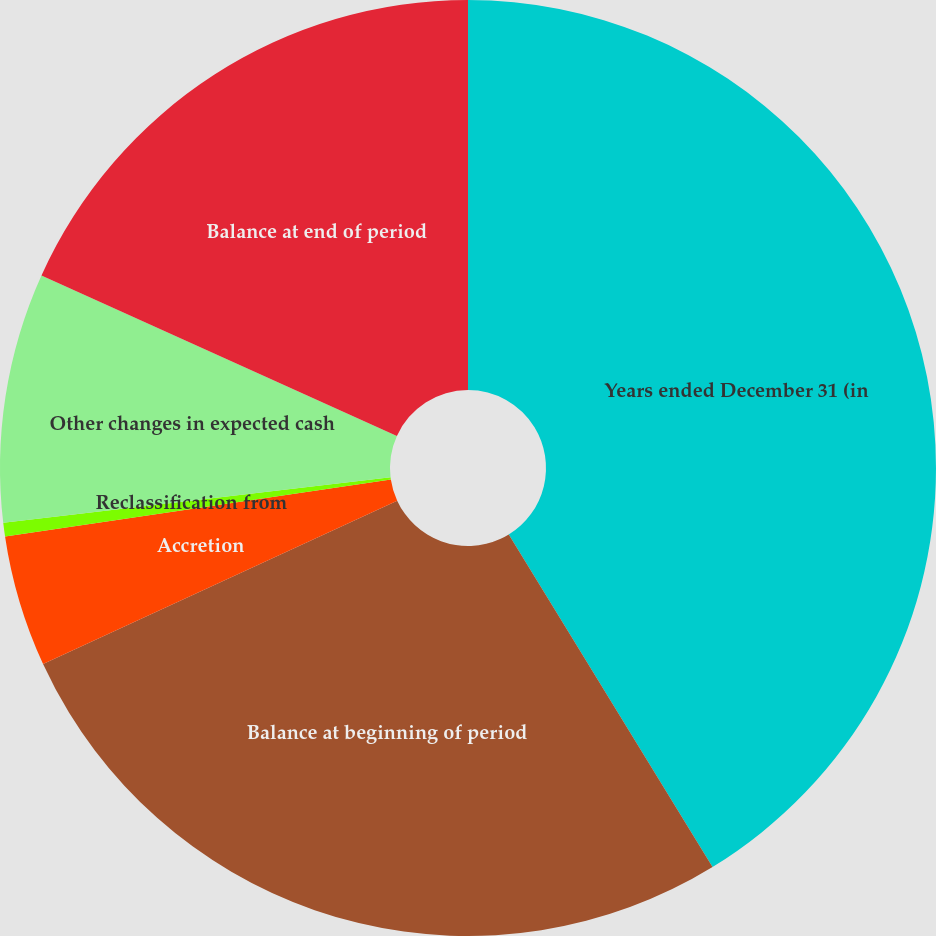Convert chart. <chart><loc_0><loc_0><loc_500><loc_500><pie_chart><fcel>Years ended December 31 (in<fcel>Balance at beginning of period<fcel>Accretion<fcel>Reclassification from<fcel>Other changes in expected cash<fcel>Balance at end of period<nl><fcel>41.25%<fcel>26.87%<fcel>4.54%<fcel>0.47%<fcel>8.62%<fcel>18.25%<nl></chart> 